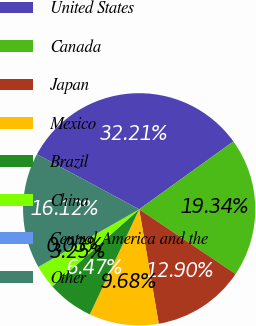Convert chart. <chart><loc_0><loc_0><loc_500><loc_500><pie_chart><fcel>United States<fcel>Canada<fcel>Japan<fcel>Mexico<fcel>Brazil<fcel>China<fcel>Central America and the<fcel>Other<nl><fcel>32.21%<fcel>19.34%<fcel>12.9%<fcel>9.68%<fcel>6.47%<fcel>3.25%<fcel>0.03%<fcel>16.12%<nl></chart> 